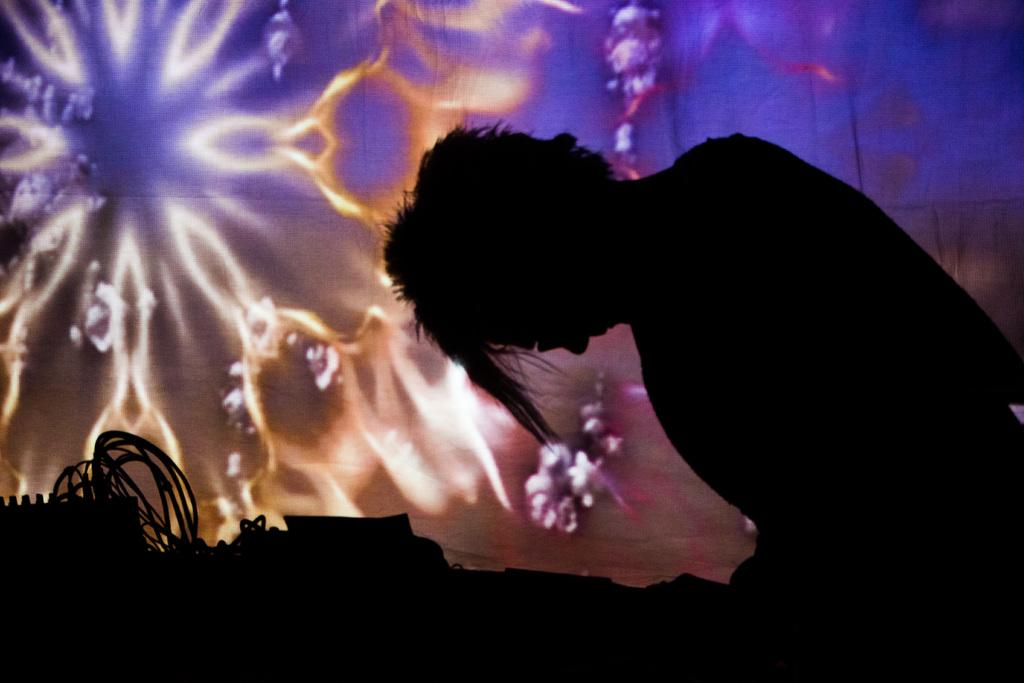What is the main subject of the image? There is a person in the image. Can you describe the background of the image? There are objects in the background of the image. How many grapes are hanging from the person's ear in the image? There are no grapes present in the image, and the person's ear is not mentioned in the provided facts. 